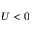Convert formula to latex. <formula><loc_0><loc_0><loc_500><loc_500>U < 0</formula> 